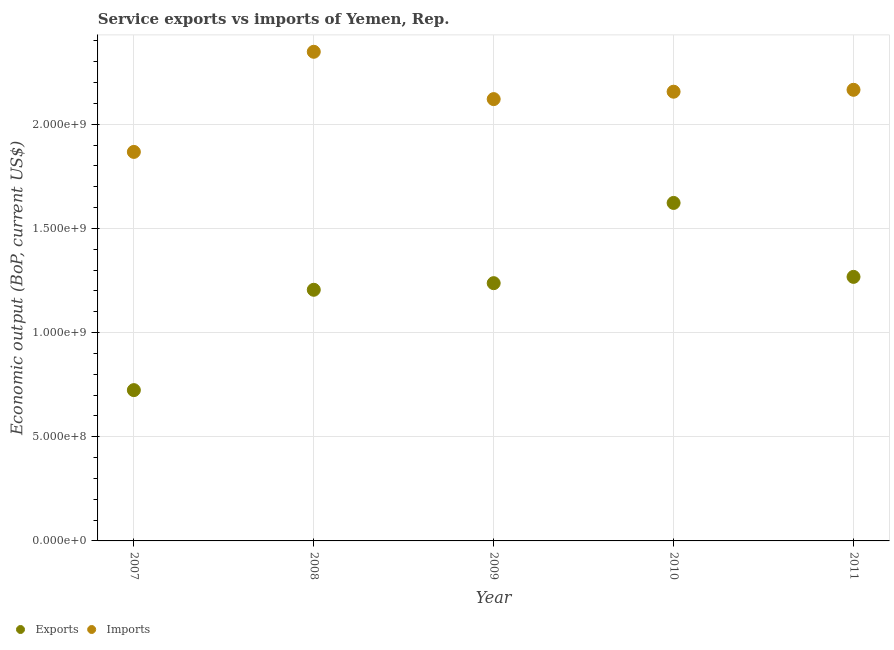Is the number of dotlines equal to the number of legend labels?
Keep it short and to the point. Yes. What is the amount of service exports in 2008?
Provide a short and direct response. 1.21e+09. Across all years, what is the maximum amount of service imports?
Offer a very short reply. 2.35e+09. Across all years, what is the minimum amount of service imports?
Provide a short and direct response. 1.87e+09. In which year was the amount of service imports maximum?
Give a very brief answer. 2008. What is the total amount of service imports in the graph?
Ensure brevity in your answer.  1.07e+1. What is the difference between the amount of service exports in 2007 and that in 2010?
Keep it short and to the point. -8.98e+08. What is the difference between the amount of service exports in 2011 and the amount of service imports in 2007?
Your answer should be compact. -6.00e+08. What is the average amount of service imports per year?
Offer a very short reply. 2.13e+09. In the year 2007, what is the difference between the amount of service imports and amount of service exports?
Keep it short and to the point. 1.14e+09. In how many years, is the amount of service imports greater than 1200000000 US$?
Make the answer very short. 5. What is the ratio of the amount of service imports in 2010 to that in 2011?
Provide a short and direct response. 1. Is the amount of service imports in 2007 less than that in 2010?
Ensure brevity in your answer.  Yes. What is the difference between the highest and the second highest amount of service exports?
Your response must be concise. 3.55e+08. What is the difference between the highest and the lowest amount of service exports?
Provide a succinct answer. 8.98e+08. Is the sum of the amount of service exports in 2010 and 2011 greater than the maximum amount of service imports across all years?
Your answer should be very brief. Yes. How many dotlines are there?
Ensure brevity in your answer.  2. What is the difference between two consecutive major ticks on the Y-axis?
Ensure brevity in your answer.  5.00e+08. Are the values on the major ticks of Y-axis written in scientific E-notation?
Provide a succinct answer. Yes. Does the graph contain any zero values?
Keep it short and to the point. No. Where does the legend appear in the graph?
Your answer should be compact. Bottom left. How are the legend labels stacked?
Give a very brief answer. Horizontal. What is the title of the graph?
Ensure brevity in your answer.  Service exports vs imports of Yemen, Rep. Does "Canada" appear as one of the legend labels in the graph?
Offer a very short reply. No. What is the label or title of the X-axis?
Give a very brief answer. Year. What is the label or title of the Y-axis?
Your answer should be compact. Economic output (BoP, current US$). What is the Economic output (BoP, current US$) of Exports in 2007?
Offer a terse response. 7.24e+08. What is the Economic output (BoP, current US$) of Imports in 2007?
Offer a terse response. 1.87e+09. What is the Economic output (BoP, current US$) of Exports in 2008?
Make the answer very short. 1.21e+09. What is the Economic output (BoP, current US$) in Imports in 2008?
Keep it short and to the point. 2.35e+09. What is the Economic output (BoP, current US$) in Exports in 2009?
Ensure brevity in your answer.  1.24e+09. What is the Economic output (BoP, current US$) in Imports in 2009?
Keep it short and to the point. 2.12e+09. What is the Economic output (BoP, current US$) of Exports in 2010?
Your answer should be very brief. 1.62e+09. What is the Economic output (BoP, current US$) of Imports in 2010?
Ensure brevity in your answer.  2.16e+09. What is the Economic output (BoP, current US$) of Exports in 2011?
Provide a succinct answer. 1.27e+09. What is the Economic output (BoP, current US$) in Imports in 2011?
Keep it short and to the point. 2.17e+09. Across all years, what is the maximum Economic output (BoP, current US$) of Exports?
Ensure brevity in your answer.  1.62e+09. Across all years, what is the maximum Economic output (BoP, current US$) in Imports?
Make the answer very short. 2.35e+09. Across all years, what is the minimum Economic output (BoP, current US$) in Exports?
Give a very brief answer. 7.24e+08. Across all years, what is the minimum Economic output (BoP, current US$) in Imports?
Offer a terse response. 1.87e+09. What is the total Economic output (BoP, current US$) in Exports in the graph?
Offer a terse response. 6.06e+09. What is the total Economic output (BoP, current US$) of Imports in the graph?
Your response must be concise. 1.07e+1. What is the difference between the Economic output (BoP, current US$) of Exports in 2007 and that in 2008?
Make the answer very short. -4.82e+08. What is the difference between the Economic output (BoP, current US$) in Imports in 2007 and that in 2008?
Make the answer very short. -4.81e+08. What is the difference between the Economic output (BoP, current US$) in Exports in 2007 and that in 2009?
Provide a succinct answer. -5.13e+08. What is the difference between the Economic output (BoP, current US$) in Imports in 2007 and that in 2009?
Offer a very short reply. -2.53e+08. What is the difference between the Economic output (BoP, current US$) of Exports in 2007 and that in 2010?
Make the answer very short. -8.98e+08. What is the difference between the Economic output (BoP, current US$) of Imports in 2007 and that in 2010?
Offer a terse response. -2.89e+08. What is the difference between the Economic output (BoP, current US$) of Exports in 2007 and that in 2011?
Your answer should be very brief. -5.44e+08. What is the difference between the Economic output (BoP, current US$) in Imports in 2007 and that in 2011?
Keep it short and to the point. -2.98e+08. What is the difference between the Economic output (BoP, current US$) of Exports in 2008 and that in 2009?
Provide a short and direct response. -3.18e+07. What is the difference between the Economic output (BoP, current US$) of Imports in 2008 and that in 2009?
Give a very brief answer. 2.27e+08. What is the difference between the Economic output (BoP, current US$) in Exports in 2008 and that in 2010?
Provide a succinct answer. -4.17e+08. What is the difference between the Economic output (BoP, current US$) of Imports in 2008 and that in 2010?
Your answer should be compact. 1.92e+08. What is the difference between the Economic output (BoP, current US$) in Exports in 2008 and that in 2011?
Offer a terse response. -6.19e+07. What is the difference between the Economic output (BoP, current US$) of Imports in 2008 and that in 2011?
Provide a short and direct response. 1.82e+08. What is the difference between the Economic output (BoP, current US$) of Exports in 2009 and that in 2010?
Make the answer very short. -3.85e+08. What is the difference between the Economic output (BoP, current US$) in Imports in 2009 and that in 2010?
Give a very brief answer. -3.55e+07. What is the difference between the Economic output (BoP, current US$) of Exports in 2009 and that in 2011?
Your answer should be very brief. -3.02e+07. What is the difference between the Economic output (BoP, current US$) of Imports in 2009 and that in 2011?
Your answer should be compact. -4.47e+07. What is the difference between the Economic output (BoP, current US$) in Exports in 2010 and that in 2011?
Ensure brevity in your answer.  3.55e+08. What is the difference between the Economic output (BoP, current US$) in Imports in 2010 and that in 2011?
Your answer should be very brief. -9.16e+06. What is the difference between the Economic output (BoP, current US$) of Exports in 2007 and the Economic output (BoP, current US$) of Imports in 2008?
Your answer should be compact. -1.62e+09. What is the difference between the Economic output (BoP, current US$) in Exports in 2007 and the Economic output (BoP, current US$) in Imports in 2009?
Your answer should be very brief. -1.40e+09. What is the difference between the Economic output (BoP, current US$) of Exports in 2007 and the Economic output (BoP, current US$) of Imports in 2010?
Make the answer very short. -1.43e+09. What is the difference between the Economic output (BoP, current US$) of Exports in 2007 and the Economic output (BoP, current US$) of Imports in 2011?
Offer a very short reply. -1.44e+09. What is the difference between the Economic output (BoP, current US$) in Exports in 2008 and the Economic output (BoP, current US$) in Imports in 2009?
Ensure brevity in your answer.  -9.15e+08. What is the difference between the Economic output (BoP, current US$) of Exports in 2008 and the Economic output (BoP, current US$) of Imports in 2010?
Your answer should be compact. -9.51e+08. What is the difference between the Economic output (BoP, current US$) in Exports in 2008 and the Economic output (BoP, current US$) in Imports in 2011?
Your answer should be compact. -9.60e+08. What is the difference between the Economic output (BoP, current US$) in Exports in 2009 and the Economic output (BoP, current US$) in Imports in 2010?
Make the answer very short. -9.19e+08. What is the difference between the Economic output (BoP, current US$) of Exports in 2009 and the Economic output (BoP, current US$) of Imports in 2011?
Make the answer very short. -9.28e+08. What is the difference between the Economic output (BoP, current US$) in Exports in 2010 and the Economic output (BoP, current US$) in Imports in 2011?
Your answer should be compact. -5.43e+08. What is the average Economic output (BoP, current US$) of Exports per year?
Offer a terse response. 1.21e+09. What is the average Economic output (BoP, current US$) of Imports per year?
Keep it short and to the point. 2.13e+09. In the year 2007, what is the difference between the Economic output (BoP, current US$) in Exports and Economic output (BoP, current US$) in Imports?
Your response must be concise. -1.14e+09. In the year 2008, what is the difference between the Economic output (BoP, current US$) of Exports and Economic output (BoP, current US$) of Imports?
Give a very brief answer. -1.14e+09. In the year 2009, what is the difference between the Economic output (BoP, current US$) of Exports and Economic output (BoP, current US$) of Imports?
Make the answer very short. -8.83e+08. In the year 2010, what is the difference between the Economic output (BoP, current US$) in Exports and Economic output (BoP, current US$) in Imports?
Keep it short and to the point. -5.34e+08. In the year 2011, what is the difference between the Economic output (BoP, current US$) of Exports and Economic output (BoP, current US$) of Imports?
Offer a terse response. -8.98e+08. What is the ratio of the Economic output (BoP, current US$) of Exports in 2007 to that in 2008?
Make the answer very short. 0.6. What is the ratio of the Economic output (BoP, current US$) in Imports in 2007 to that in 2008?
Give a very brief answer. 0.8. What is the ratio of the Economic output (BoP, current US$) of Exports in 2007 to that in 2009?
Provide a short and direct response. 0.59. What is the ratio of the Economic output (BoP, current US$) of Imports in 2007 to that in 2009?
Offer a terse response. 0.88. What is the ratio of the Economic output (BoP, current US$) of Exports in 2007 to that in 2010?
Ensure brevity in your answer.  0.45. What is the ratio of the Economic output (BoP, current US$) of Imports in 2007 to that in 2010?
Your response must be concise. 0.87. What is the ratio of the Economic output (BoP, current US$) of Exports in 2007 to that in 2011?
Offer a terse response. 0.57. What is the ratio of the Economic output (BoP, current US$) of Imports in 2007 to that in 2011?
Offer a terse response. 0.86. What is the ratio of the Economic output (BoP, current US$) in Exports in 2008 to that in 2009?
Keep it short and to the point. 0.97. What is the ratio of the Economic output (BoP, current US$) of Imports in 2008 to that in 2009?
Your response must be concise. 1.11. What is the ratio of the Economic output (BoP, current US$) of Exports in 2008 to that in 2010?
Keep it short and to the point. 0.74. What is the ratio of the Economic output (BoP, current US$) in Imports in 2008 to that in 2010?
Provide a short and direct response. 1.09. What is the ratio of the Economic output (BoP, current US$) of Exports in 2008 to that in 2011?
Provide a succinct answer. 0.95. What is the ratio of the Economic output (BoP, current US$) of Imports in 2008 to that in 2011?
Make the answer very short. 1.08. What is the ratio of the Economic output (BoP, current US$) in Exports in 2009 to that in 2010?
Ensure brevity in your answer.  0.76. What is the ratio of the Economic output (BoP, current US$) in Imports in 2009 to that in 2010?
Make the answer very short. 0.98. What is the ratio of the Economic output (BoP, current US$) in Exports in 2009 to that in 2011?
Your answer should be compact. 0.98. What is the ratio of the Economic output (BoP, current US$) of Imports in 2009 to that in 2011?
Your answer should be very brief. 0.98. What is the ratio of the Economic output (BoP, current US$) in Exports in 2010 to that in 2011?
Your response must be concise. 1.28. What is the ratio of the Economic output (BoP, current US$) in Imports in 2010 to that in 2011?
Your response must be concise. 1. What is the difference between the highest and the second highest Economic output (BoP, current US$) in Exports?
Provide a succinct answer. 3.55e+08. What is the difference between the highest and the second highest Economic output (BoP, current US$) in Imports?
Keep it short and to the point. 1.82e+08. What is the difference between the highest and the lowest Economic output (BoP, current US$) in Exports?
Your response must be concise. 8.98e+08. What is the difference between the highest and the lowest Economic output (BoP, current US$) of Imports?
Offer a terse response. 4.81e+08. 